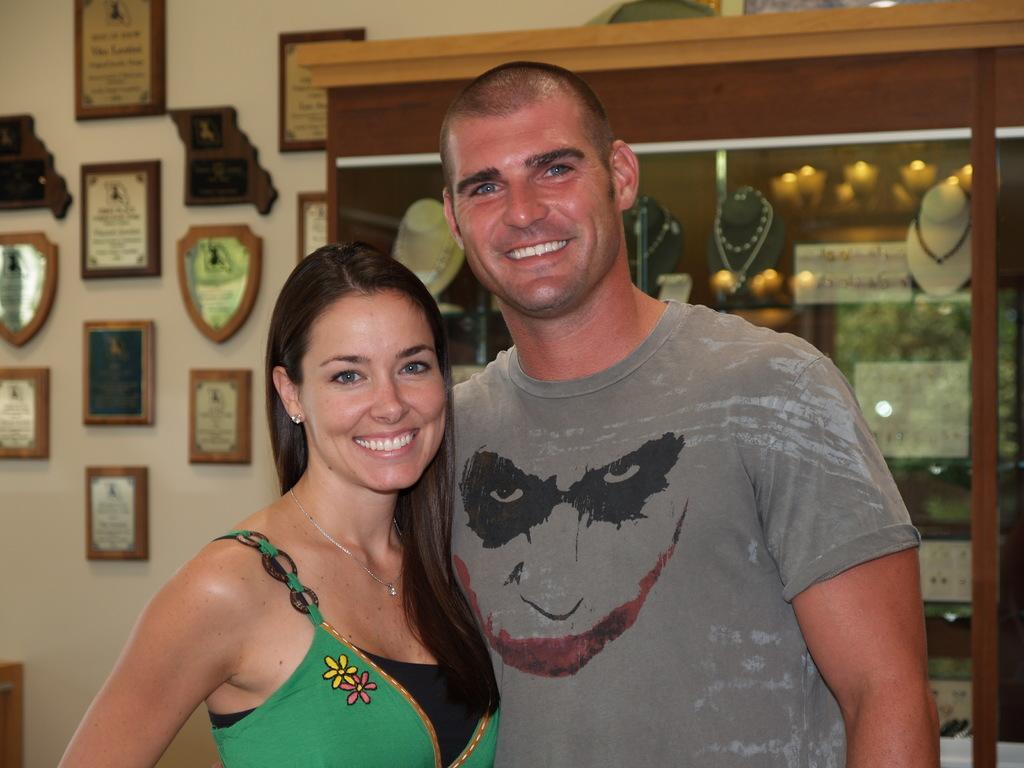Could you give a brief overview of what you see in this image? In the foreground of this image, there is a couple standing and having smile on their faces. In the background, there are frames on the wall, chains and necklaces to the mannequin inside the cupboard. 